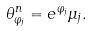<formula> <loc_0><loc_0><loc_500><loc_500>\theta ^ { n } _ { \varphi _ { j } } = e ^ { \varphi _ { j } } \mu _ { j } .</formula> 